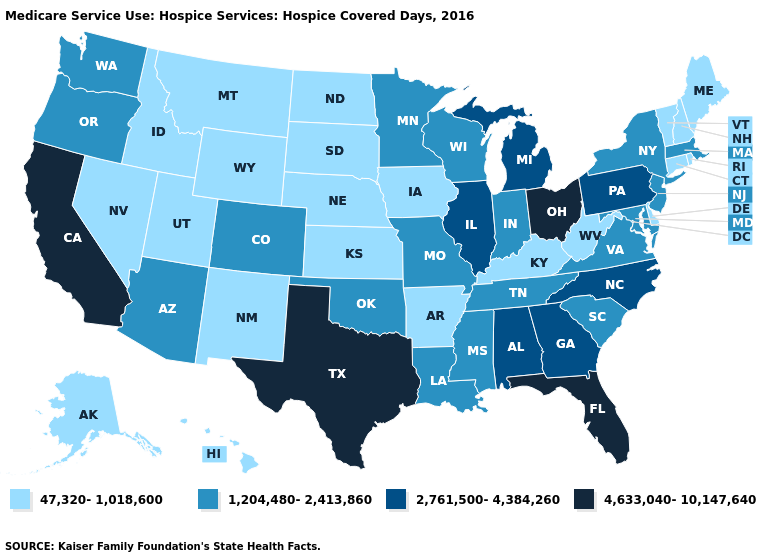What is the lowest value in the USA?
Be succinct. 47,320-1,018,600. Name the states that have a value in the range 2,761,500-4,384,260?
Write a very short answer. Alabama, Georgia, Illinois, Michigan, North Carolina, Pennsylvania. What is the value of Massachusetts?
Short answer required. 1,204,480-2,413,860. Name the states that have a value in the range 4,633,040-10,147,640?
Concise answer only. California, Florida, Ohio, Texas. Does the map have missing data?
Concise answer only. No. How many symbols are there in the legend?
Answer briefly. 4. Among the states that border Wyoming , does Nebraska have the highest value?
Be succinct. No. What is the lowest value in states that border Iowa?
Write a very short answer. 47,320-1,018,600. What is the value of Oregon?
Short answer required. 1,204,480-2,413,860. Name the states that have a value in the range 1,204,480-2,413,860?
Quick response, please. Arizona, Colorado, Indiana, Louisiana, Maryland, Massachusetts, Minnesota, Mississippi, Missouri, New Jersey, New York, Oklahoma, Oregon, South Carolina, Tennessee, Virginia, Washington, Wisconsin. What is the value of Virginia?
Quick response, please. 1,204,480-2,413,860. Does Delaware have a lower value than Maine?
Quick response, please. No. Which states have the lowest value in the USA?
Concise answer only. Alaska, Arkansas, Connecticut, Delaware, Hawaii, Idaho, Iowa, Kansas, Kentucky, Maine, Montana, Nebraska, Nevada, New Hampshire, New Mexico, North Dakota, Rhode Island, South Dakota, Utah, Vermont, West Virginia, Wyoming. Is the legend a continuous bar?
Concise answer only. No. What is the lowest value in the South?
Write a very short answer. 47,320-1,018,600. 